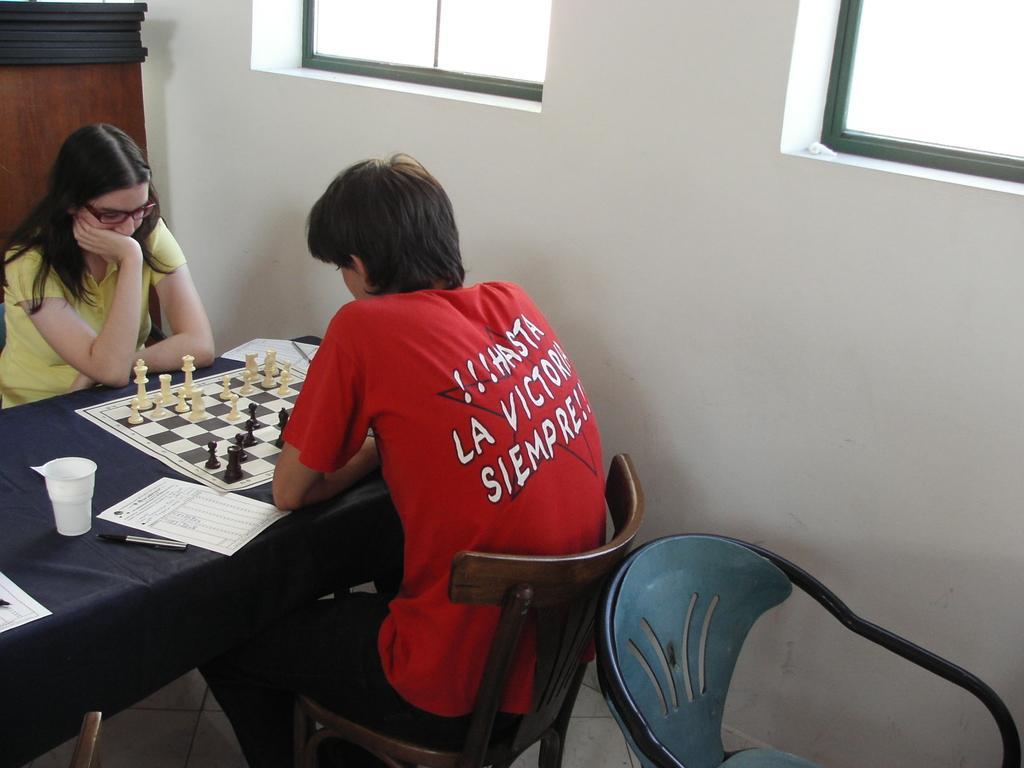In one or two sentences, can you explain what this image depicts? a man and a woman sitting on chairs in front of a table. On the table i can see a paper, chess board and a cup. in the background i can see the wall and the window. 